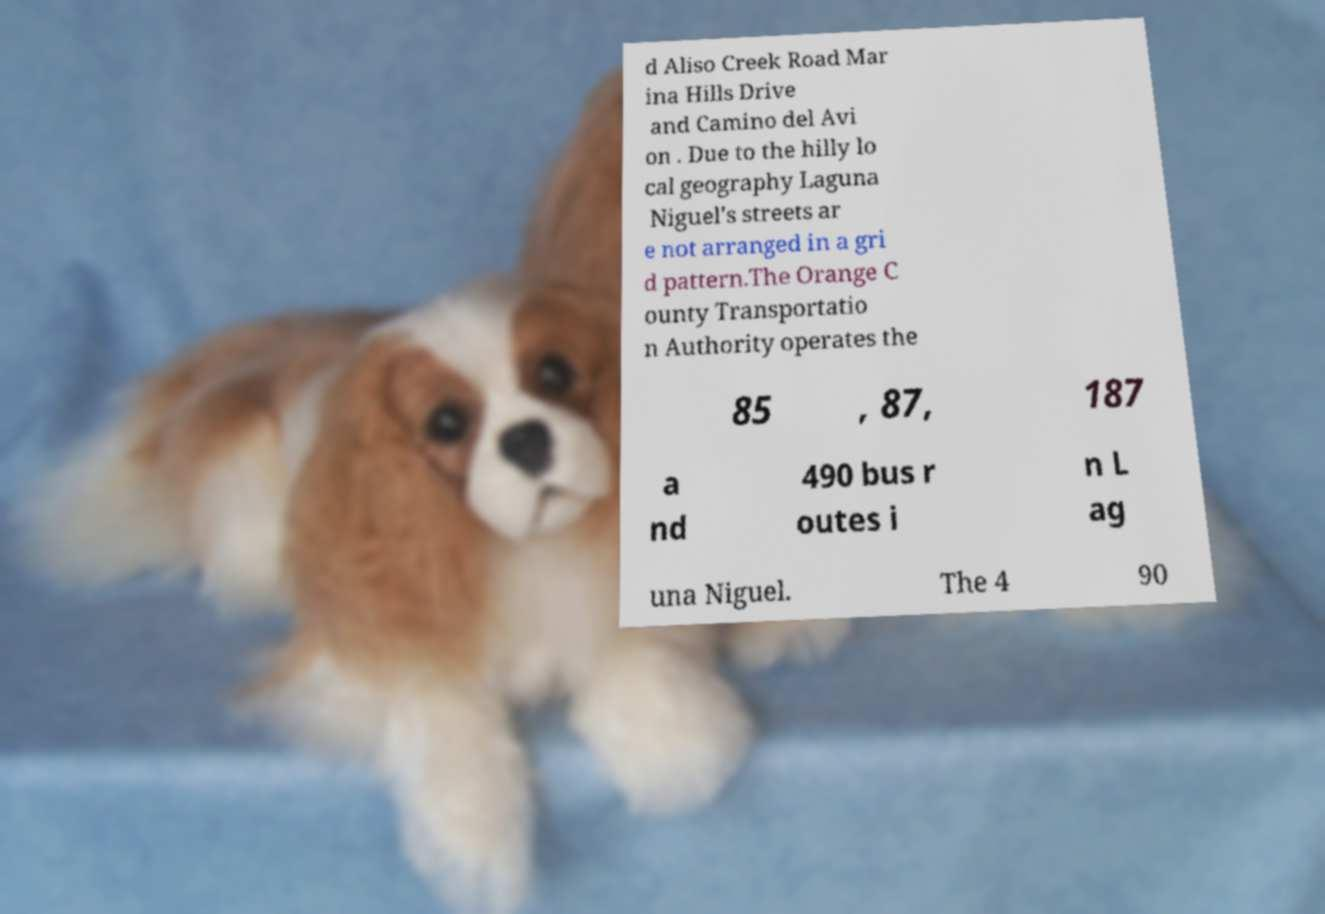Please read and relay the text visible in this image. What does it say? d Aliso Creek Road Mar ina Hills Drive and Camino del Avi on . Due to the hilly lo cal geography Laguna Niguel's streets ar e not arranged in a gri d pattern.The Orange C ounty Transportatio n Authority operates the 85 , 87, 187 a nd 490 bus r outes i n L ag una Niguel. The 4 90 